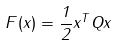Convert formula to latex. <formula><loc_0><loc_0><loc_500><loc_500>F ( x ) = { \frac { 1 } { 2 } } x ^ { T } Q x</formula> 